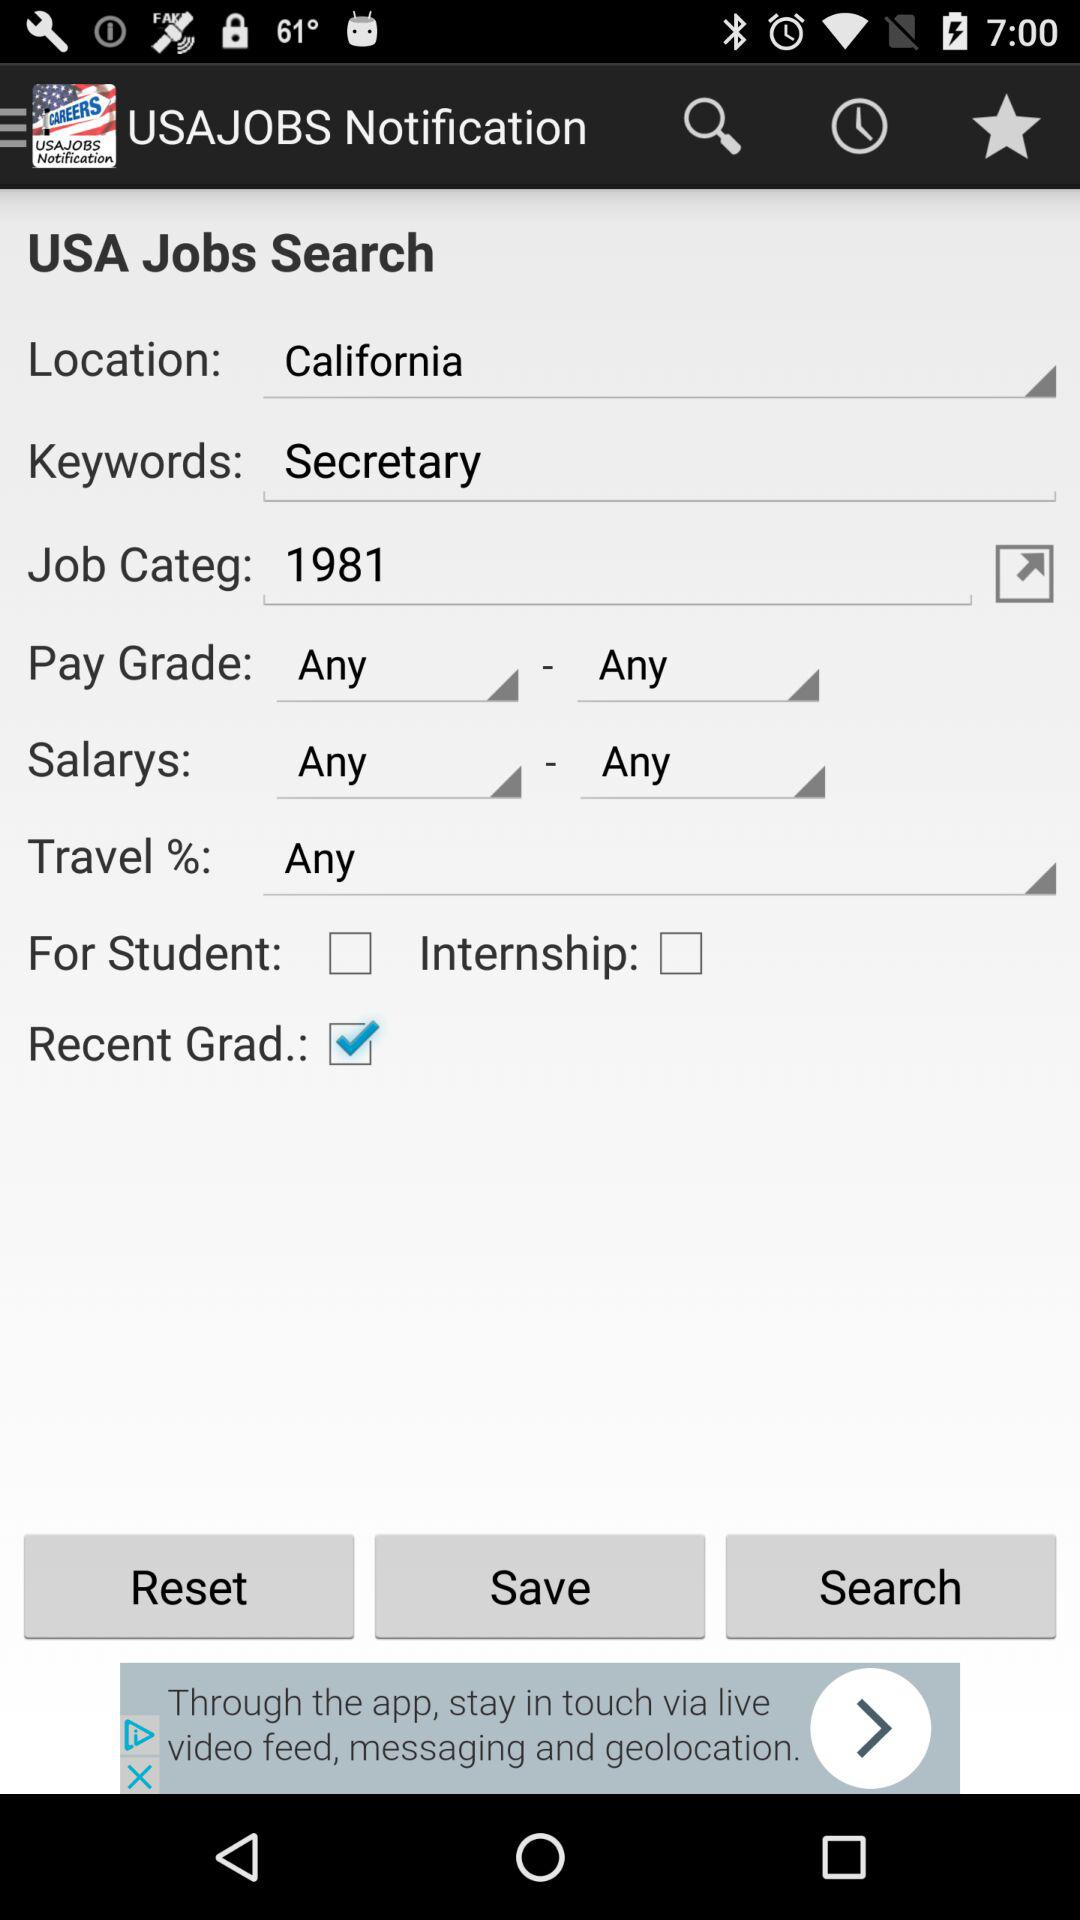What is the keyword? The keyword is "Secretary". 